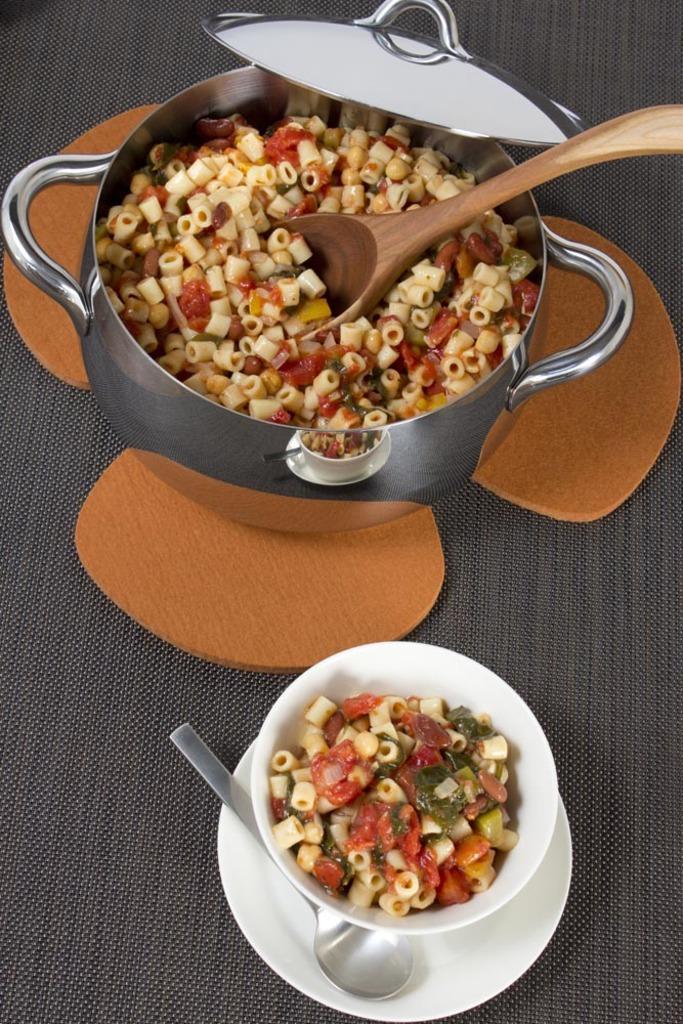In one or two sentences, can you explain what this image depicts? In this picture, we see a saucer, a spoon and a bowl containing the food item. Beside that, we see a pan or a vessel containing the wooden spoon and the food item. Beside that, we see the lid of the pan. This pan might be placed on the brown color wooden object. In the background, it is black in color and it might be a table. 